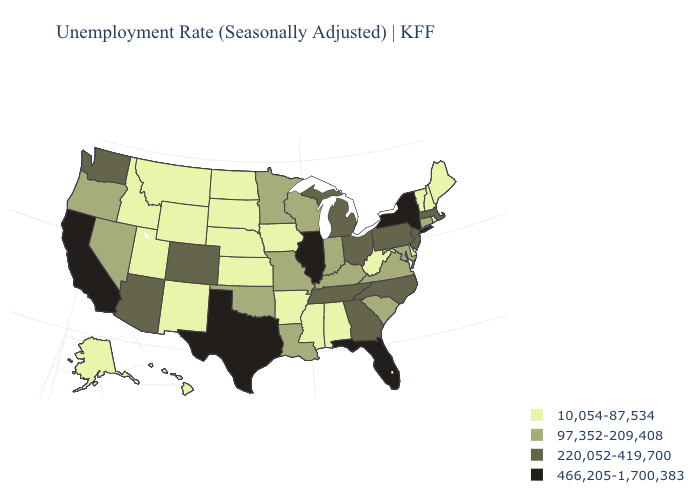Among the states that border Illinois , does Iowa have the lowest value?
Answer briefly. Yes. Name the states that have a value in the range 220,052-419,700?
Keep it brief. Arizona, Colorado, Georgia, Massachusetts, Michigan, New Jersey, North Carolina, Ohio, Pennsylvania, Tennessee, Washington. What is the lowest value in states that border Missouri?
Quick response, please. 10,054-87,534. Name the states that have a value in the range 97,352-209,408?
Concise answer only. Connecticut, Indiana, Kentucky, Louisiana, Maryland, Minnesota, Missouri, Nevada, Oklahoma, Oregon, South Carolina, Virginia, Wisconsin. Which states have the lowest value in the USA?
Short answer required. Alabama, Alaska, Arkansas, Delaware, Hawaii, Idaho, Iowa, Kansas, Maine, Mississippi, Montana, Nebraska, New Hampshire, New Mexico, North Dakota, Rhode Island, South Dakota, Utah, Vermont, West Virginia, Wyoming. What is the value of Arizona?
Be succinct. 220,052-419,700. Does the first symbol in the legend represent the smallest category?
Be succinct. Yes. Among the states that border Arizona , which have the lowest value?
Keep it brief. New Mexico, Utah. Name the states that have a value in the range 97,352-209,408?
Short answer required. Connecticut, Indiana, Kentucky, Louisiana, Maryland, Minnesota, Missouri, Nevada, Oklahoma, Oregon, South Carolina, Virginia, Wisconsin. Name the states that have a value in the range 220,052-419,700?
Quick response, please. Arizona, Colorado, Georgia, Massachusetts, Michigan, New Jersey, North Carolina, Ohio, Pennsylvania, Tennessee, Washington. Which states have the lowest value in the MidWest?
Answer briefly. Iowa, Kansas, Nebraska, North Dakota, South Dakota. What is the value of Utah?
Short answer required. 10,054-87,534. Does Rhode Island have the highest value in the USA?
Short answer required. No. Name the states that have a value in the range 220,052-419,700?
Concise answer only. Arizona, Colorado, Georgia, Massachusetts, Michigan, New Jersey, North Carolina, Ohio, Pennsylvania, Tennessee, Washington. What is the highest value in the South ?
Answer briefly. 466,205-1,700,383. 